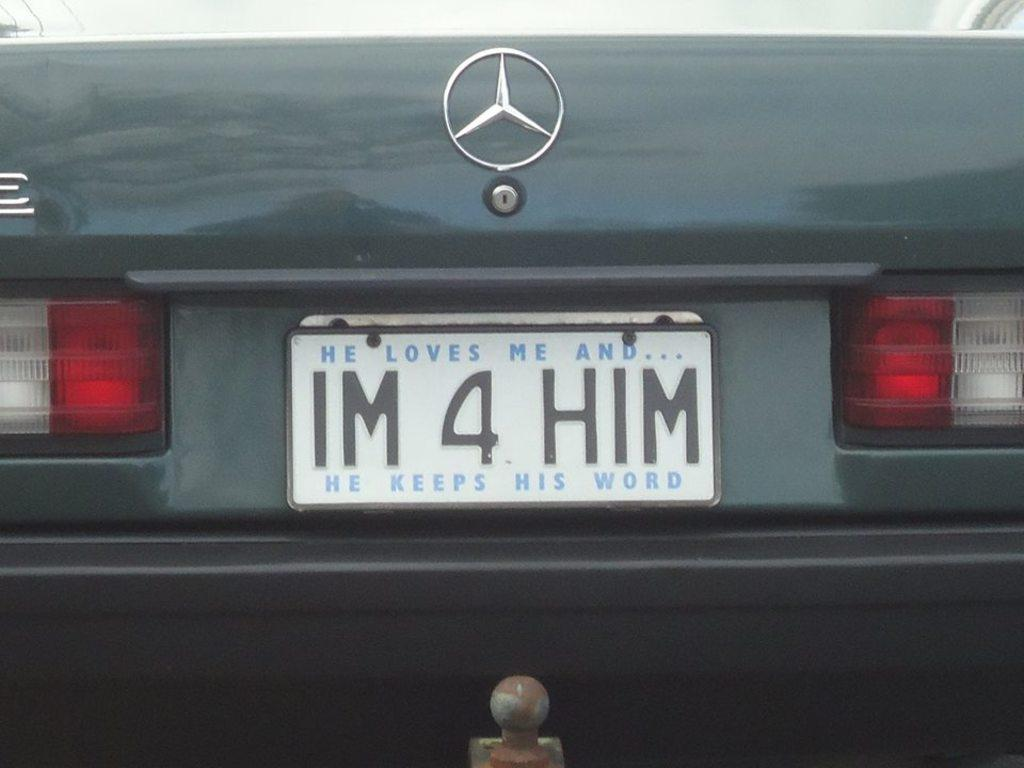<image>
Create a compact narrative representing the image presented. A license plate says He loves me and he keeps his word. 